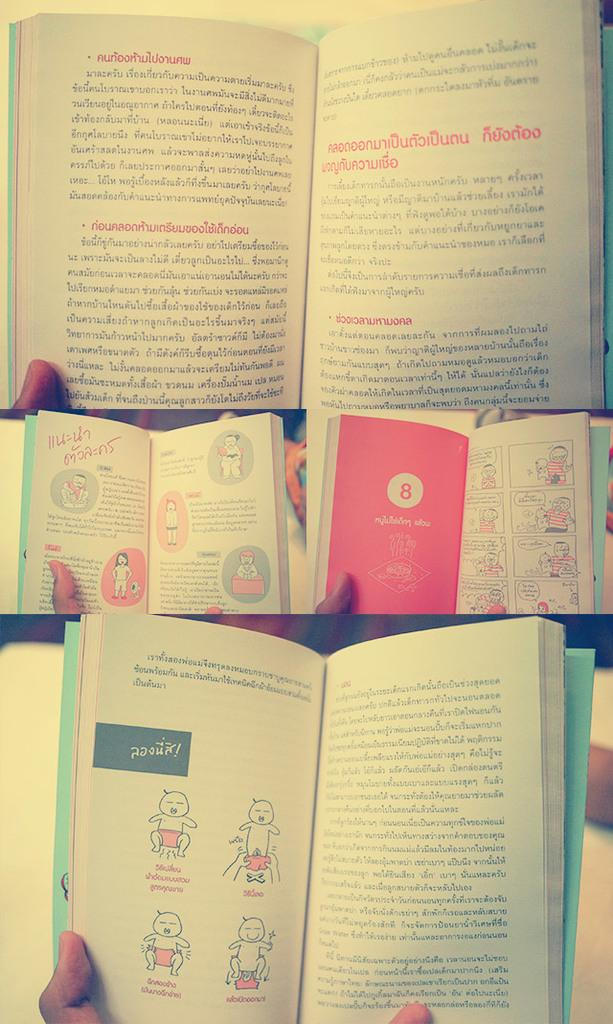<image>
Provide a brief description of the given image. Several books are open to different pages and one of those pages is all in pink with the number 8 in the middle. 